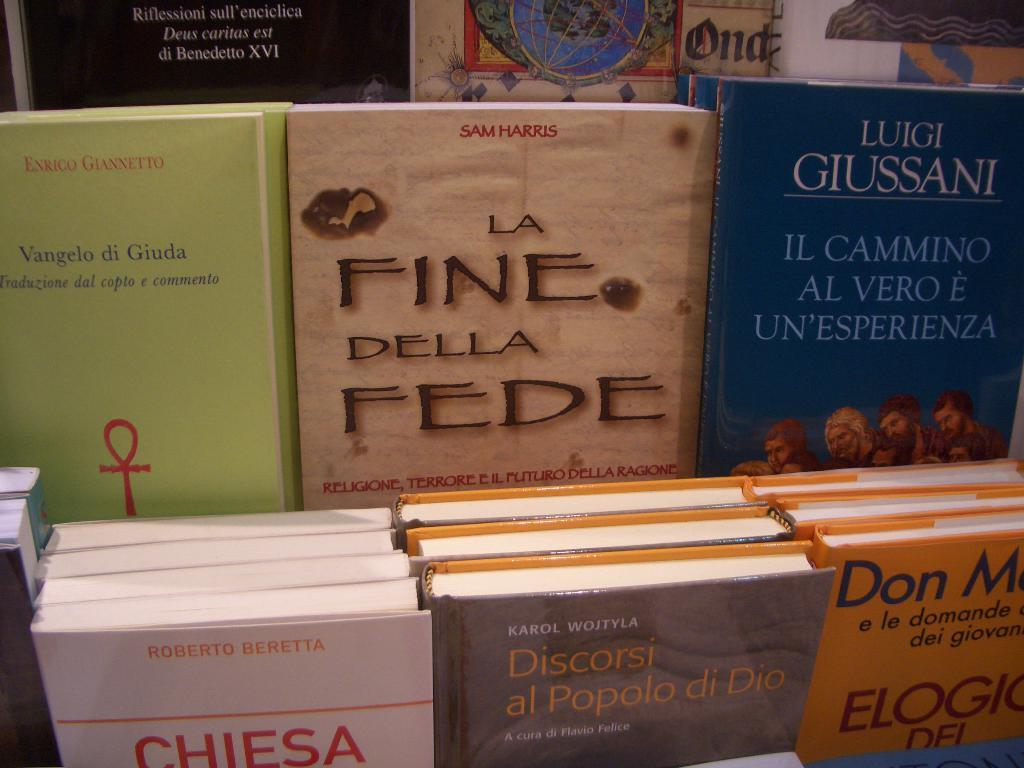<image>
Describe the image concisely. Books are on a shelf and one of them says Vangelo di Giuda. 